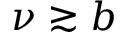Convert formula to latex. <formula><loc_0><loc_0><loc_500><loc_500>\nu \gtrsim b</formula> 